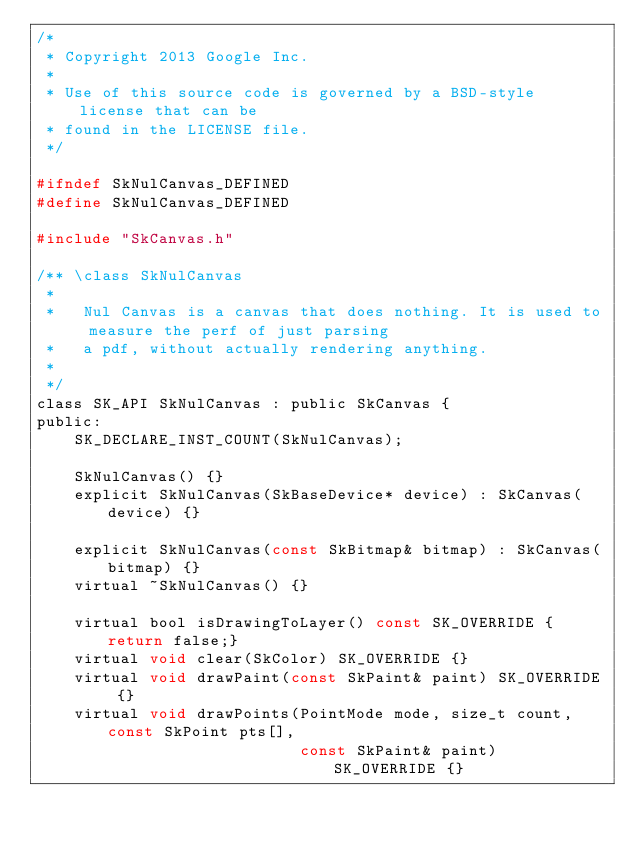<code> <loc_0><loc_0><loc_500><loc_500><_C_>/*
 * Copyright 2013 Google Inc.
 *
 * Use of this source code is governed by a BSD-style license that can be
 * found in the LICENSE file.
 */

#ifndef SkNulCanvas_DEFINED
#define SkNulCanvas_DEFINED

#include "SkCanvas.h"

/** \class SkNulCanvas
 *
 *   Nul Canvas is a canvas that does nothing. It is used to measure the perf of just parsing
 *   a pdf, without actually rendering anything.
 *
 */
class SK_API SkNulCanvas : public SkCanvas {
public:
    SK_DECLARE_INST_COUNT(SkNulCanvas);

    SkNulCanvas() {}
    explicit SkNulCanvas(SkBaseDevice* device) : SkCanvas(device) {}

    explicit SkNulCanvas(const SkBitmap& bitmap) : SkCanvas(bitmap) {}
    virtual ~SkNulCanvas() {}

    virtual bool isDrawingToLayer() const SK_OVERRIDE {return false;}
    virtual void clear(SkColor) SK_OVERRIDE {}
    virtual void drawPaint(const SkPaint& paint) SK_OVERRIDE {}
    virtual void drawPoints(PointMode mode, size_t count, const SkPoint pts[],
                            const SkPaint& paint) SK_OVERRIDE {}</code> 